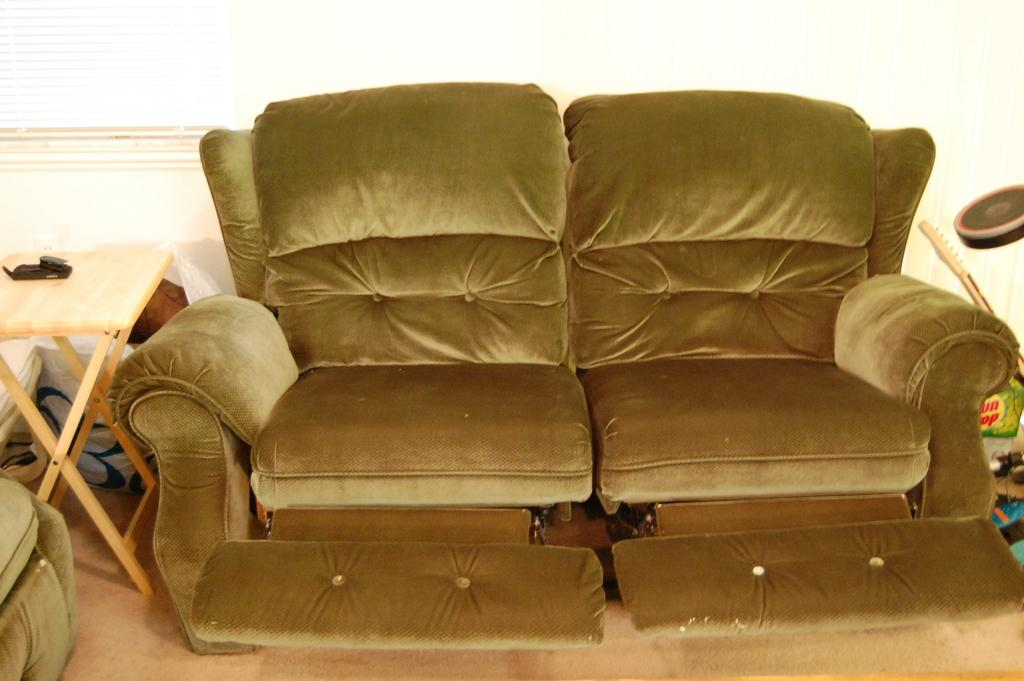What type of seating is present in the image? There is a recliner sofa in the image. What is located beside the recliner sofa? There is a table beside the recliner sofa in the image. What type of jewel is the boy wearing in the image? There is no boy or jewel present in the image. 